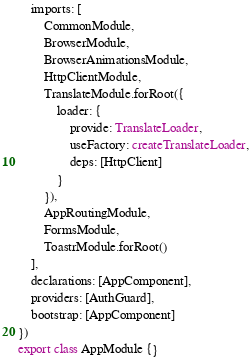Convert code to text. <code><loc_0><loc_0><loc_500><loc_500><_TypeScript_>    imports: [
        CommonModule,
        BrowserModule,
        BrowserAnimationsModule,
        HttpClientModule,
        TranslateModule.forRoot({
            loader: {
                provide: TranslateLoader,
                useFactory: createTranslateLoader,
                deps: [HttpClient]
            }
        }),
        AppRoutingModule,
        FormsModule,
        ToastrModule.forRoot()
    ],
    declarations: [AppComponent],
    providers: [AuthGuard],
    bootstrap: [AppComponent]
})
export class AppModule {}
</code> 